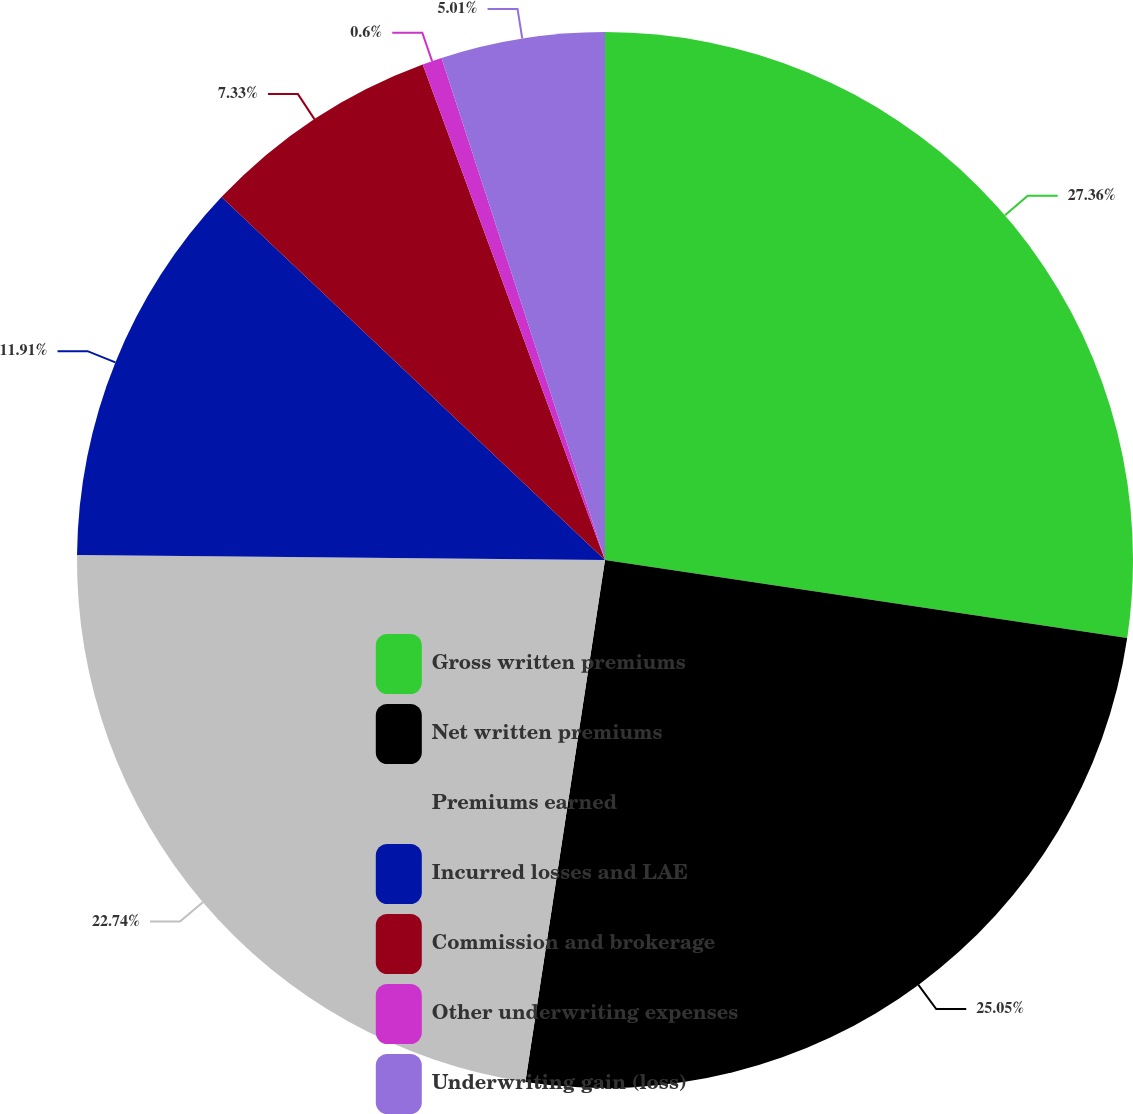Convert chart. <chart><loc_0><loc_0><loc_500><loc_500><pie_chart><fcel>Gross written premiums<fcel>Net written premiums<fcel>Premiums earned<fcel>Incurred losses and LAE<fcel>Commission and brokerage<fcel>Other underwriting expenses<fcel>Underwriting gain (loss)<nl><fcel>27.36%<fcel>25.05%<fcel>22.74%<fcel>11.91%<fcel>7.33%<fcel>0.6%<fcel>5.01%<nl></chart> 